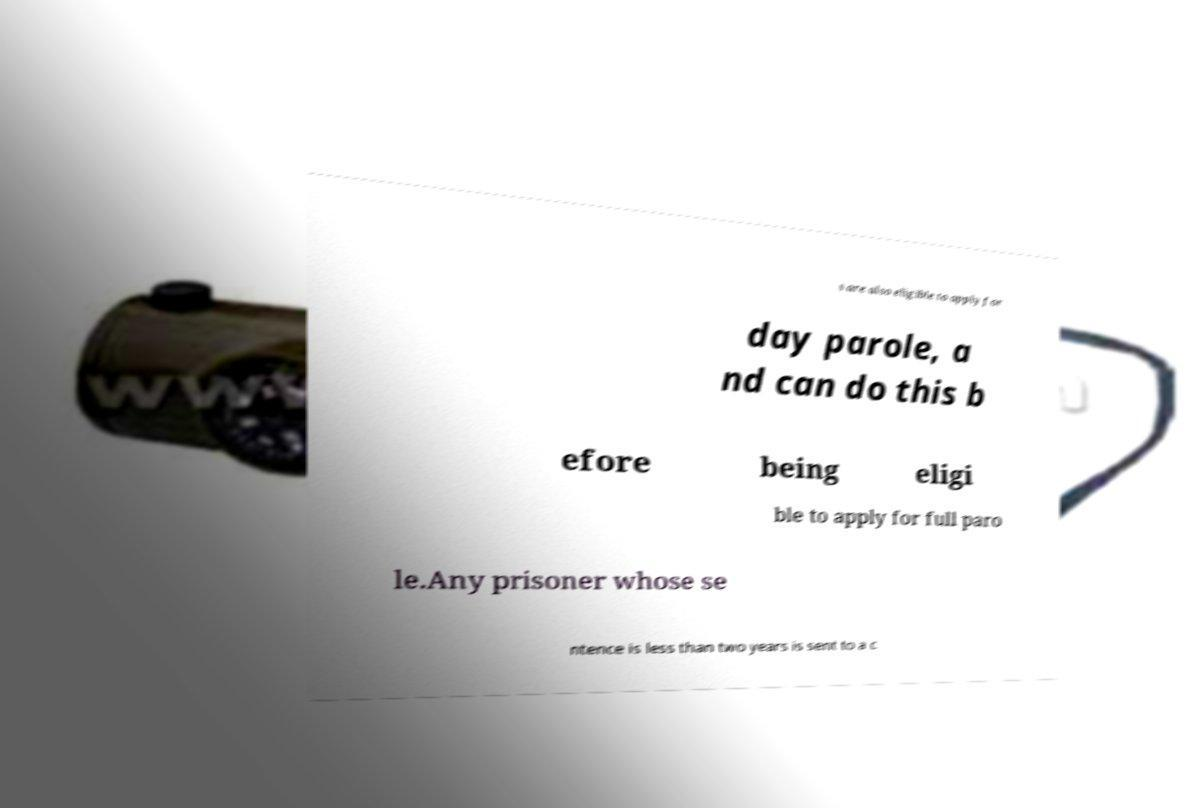Can you read and provide the text displayed in the image?This photo seems to have some interesting text. Can you extract and type it out for me? s are also eligible to apply for day parole, a nd can do this b efore being eligi ble to apply for full paro le.Any prisoner whose se ntence is less than two years is sent to a c 